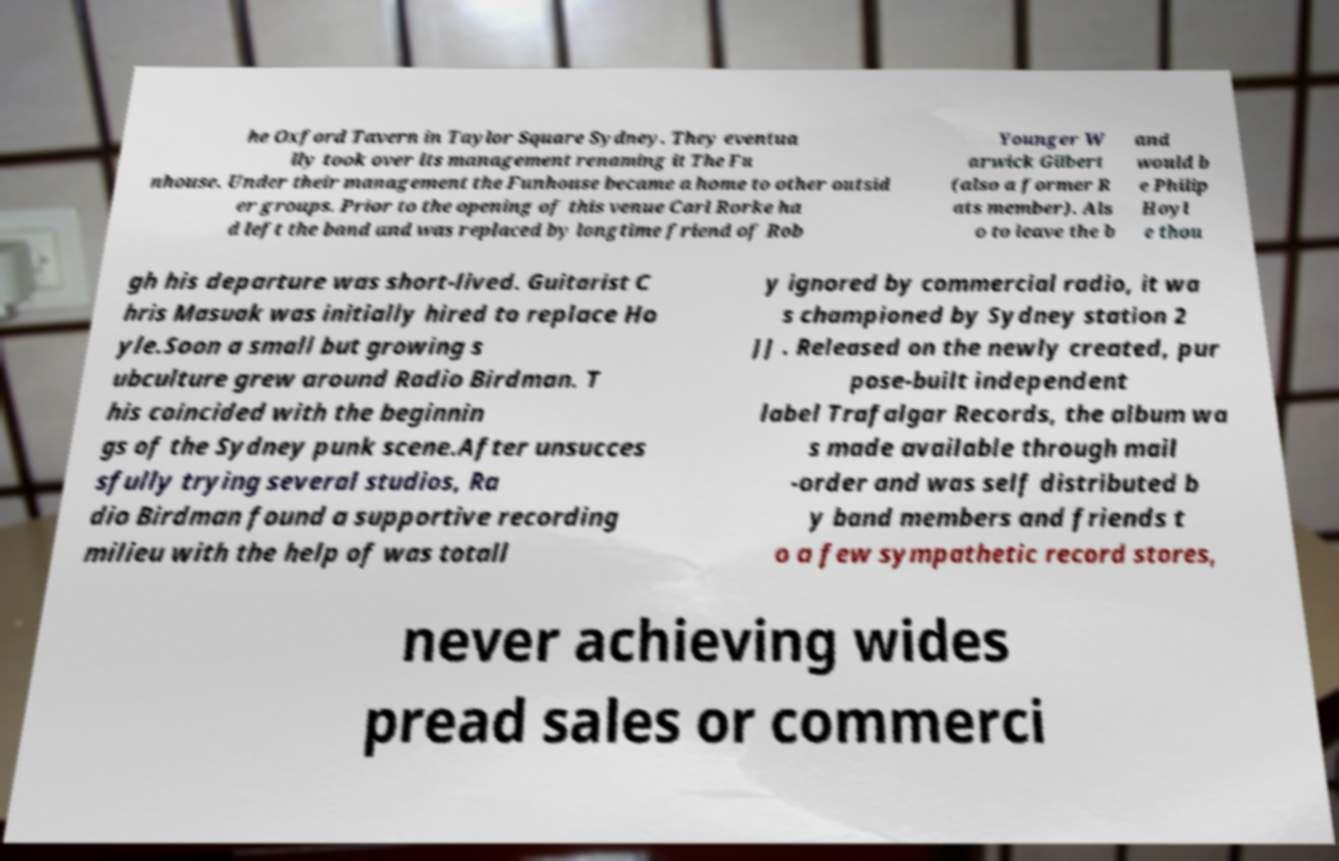What messages or text are displayed in this image? I need them in a readable, typed format. he Oxford Tavern in Taylor Square Sydney. They eventua lly took over its management renaming it The Fu nhouse. Under their management the Funhouse became a home to other outsid er groups. Prior to the opening of this venue Carl Rorke ha d left the band and was replaced by longtime friend of Rob Younger W arwick Gilbert (also a former R ats member). Als o to leave the b and would b e Philip Hoyl e thou gh his departure was short-lived. Guitarist C hris Masuak was initially hired to replace Ho yle.Soon a small but growing s ubculture grew around Radio Birdman. T his coincided with the beginnin gs of the Sydney punk scene.After unsucces sfully trying several studios, Ra dio Birdman found a supportive recording milieu with the help of was totall y ignored by commercial radio, it wa s championed by Sydney station 2 JJ . Released on the newly created, pur pose-built independent label Trafalgar Records, the album wa s made available through mail -order and was self distributed b y band members and friends t o a few sympathetic record stores, never achieving wides pread sales or commerci 